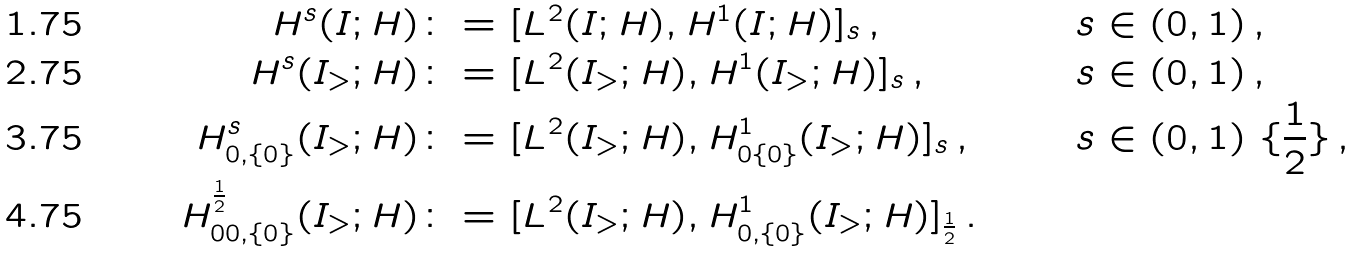Convert formula to latex. <formula><loc_0><loc_0><loc_500><loc_500>H ^ { s } ( I ; H ) & \colon = [ L ^ { 2 } ( I ; H ) , H ^ { 1 } ( I ; H ) ] _ { s } \, , & & s \in ( 0 , 1 ) \, , \\ H ^ { s } ( I _ { > } ; H ) & \colon = [ L ^ { 2 } ( I _ { > } ; H ) , H ^ { 1 } ( I _ { > } ; H ) ] _ { s } \, , & & s \in ( 0 , 1 ) \, , \\ H ^ { s } _ { 0 , \{ 0 \} } ( I _ { > } ; H ) & \colon = [ L ^ { 2 } ( I _ { > } ; H ) , H ^ { 1 } _ { 0 \{ 0 \} } ( I _ { > } ; H ) ] _ { s } \, , & & s \in ( 0 , 1 ) \ \{ \frac { 1 } { 2 } \} \, , \\ H ^ { \frac { 1 } { 2 } } _ { 0 0 , \{ 0 \} } ( I _ { > } ; H ) & \colon = [ L ^ { 2 } ( I _ { > } ; H ) , H ^ { 1 } _ { 0 , \{ 0 \} } ( I _ { > } ; H ) ] _ { \frac { 1 } { 2 } } \, . & & \</formula> 